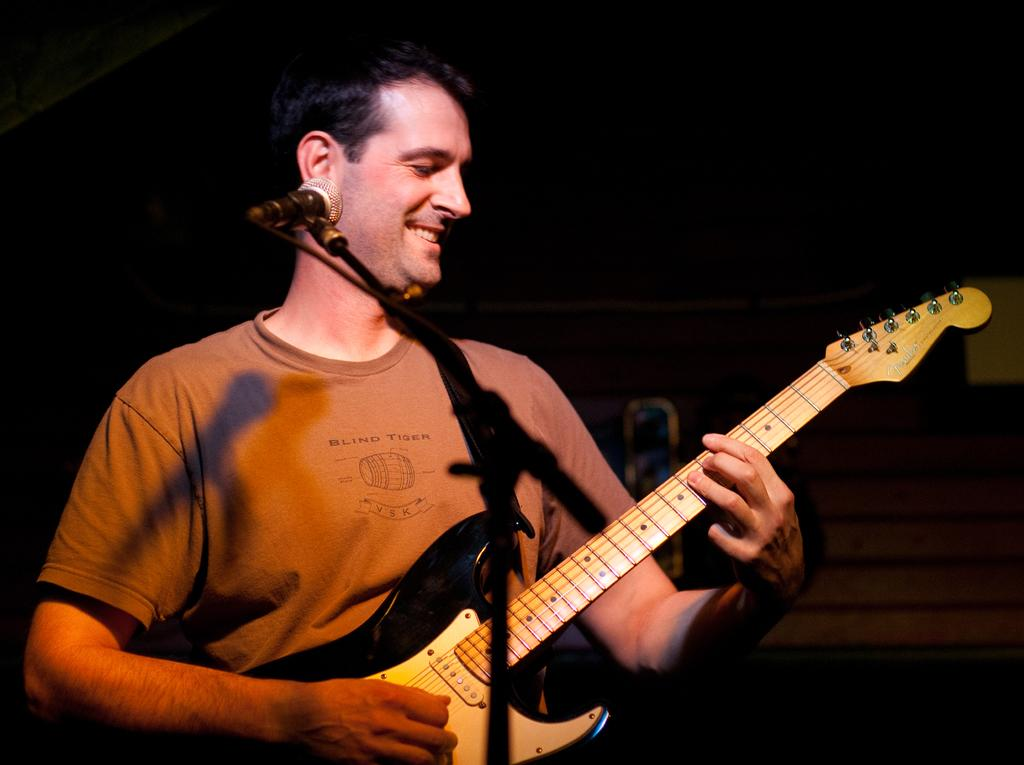Who is the person in the image? There is a man in the image. What is the man wearing? The man is wearing a brown shirt. What is the man doing in the image? The man is playing a guitar. What object is placed in front of the man? There is a microphone placed before the man. What type of haircut does the man have in the image? There is no information about the man's haircut in the image. What sign is the man holding in the image? There is no sign present in the image. 